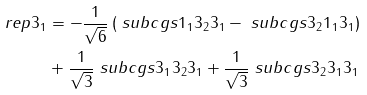<formula> <loc_0><loc_0><loc_500><loc_500>\ r e p { 3 } _ { 1 } & = - \frac { 1 } { \sqrt { 6 } } \left ( \ s u b c g s { 1 _ { 1 } } { 3 _ { 2 } } { 3 _ { 1 } } - \ s u b c g s { 3 _ { 2 } } { 1 _ { 1 } } { 3 _ { 1 } } \right ) \\ & + \frac { 1 } { \sqrt { 3 } } \ s u b c g s { 3 _ { 1 } } { 3 _ { 2 } } { 3 _ { 1 } } + \frac { 1 } { \sqrt { 3 } } \ s u b c g s { 3 _ { 2 } } { 3 _ { 1 } } { 3 _ { 1 } }</formula> 